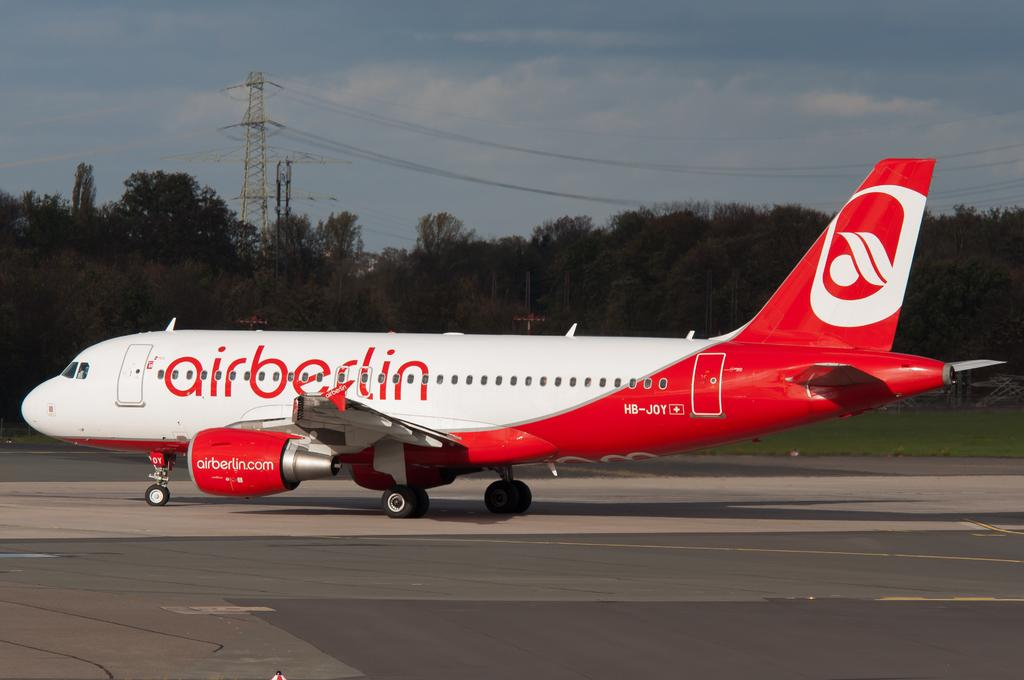What is the main subject of the image? The main subject of the image is a plane. Where is the plane located in the image? The plane is on a runway. What can be seen in the background of the image? There are trees visible in the image. What color is the tongue of the person sitting in the plane? There is no person sitting in the plane in the image, and therefore no tongue is visible. 